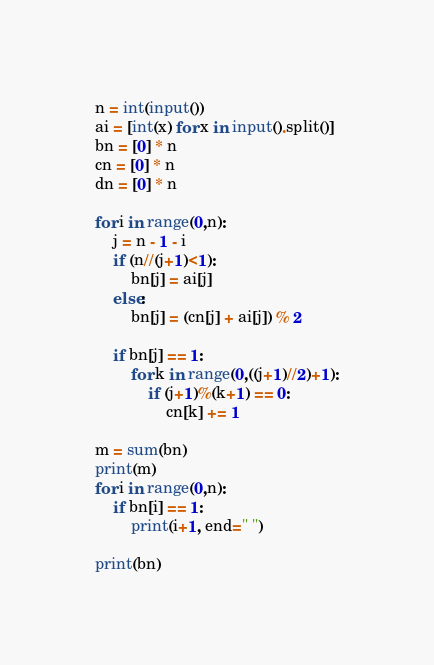Convert code to text. <code><loc_0><loc_0><loc_500><loc_500><_Python_>n = int(input())
ai = [int(x) for x in input().split()]
bn = [0] * n
cn = [0] * n
dn = [0] * n

for i in range(0,n):
    j = n - 1 - i
    if (n//(j+1)<1):
        bn[j] = ai[j]
    else:
        bn[j] = (cn[j] + ai[j]) % 2

    if bn[j] == 1:
        for k in range(0,((j+1)//2)+1):
            if (j+1)%(k+1) == 0:
                cn[k] += 1

m = sum(bn)
print(m)
for i in range(0,n):
    if bn[i] == 1:
        print(i+1, end=" ")

print(bn)
</code> 